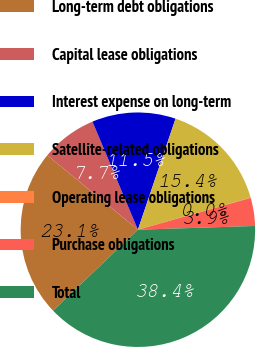Convert chart. <chart><loc_0><loc_0><loc_500><loc_500><pie_chart><fcel>Long-term debt obligations<fcel>Capital lease obligations<fcel>Interest expense on long-term<fcel>Satellite-related obligations<fcel>Operating lease obligations<fcel>Purchase obligations<fcel>Total<nl><fcel>23.08%<fcel>7.71%<fcel>11.54%<fcel>15.38%<fcel>0.04%<fcel>3.87%<fcel>38.39%<nl></chart> 